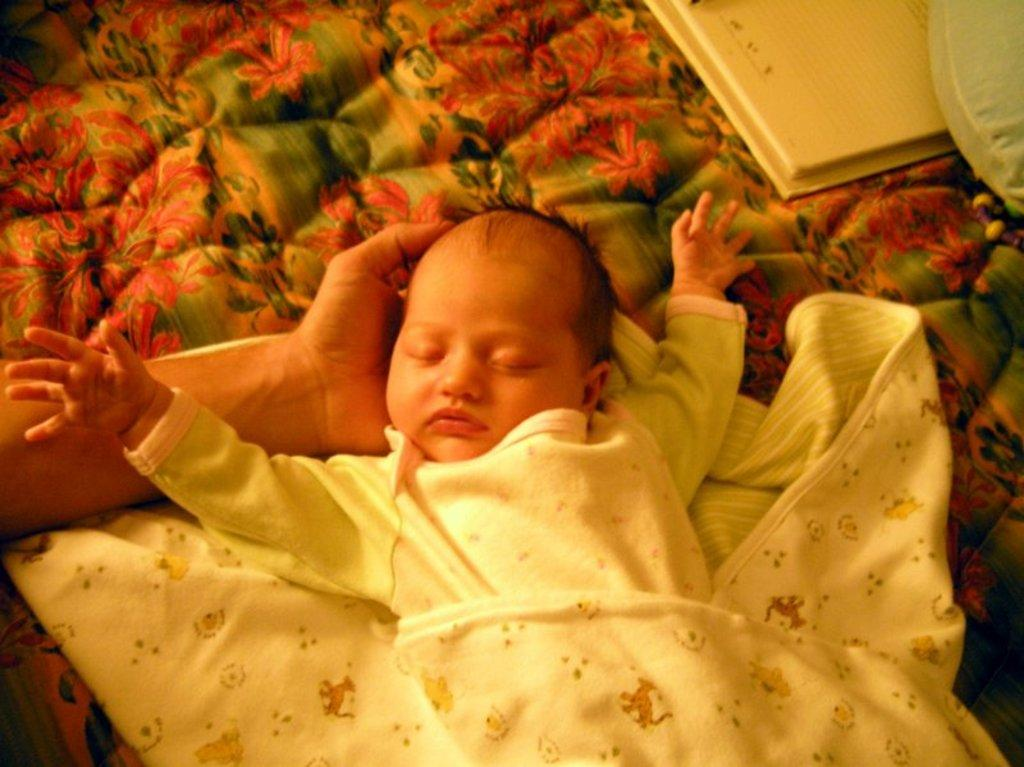What is the main subject of the image? There is a child in the image. What is the child wearing? The child is wearing a white dress. What other objects can be seen in the image? There is a cloth and a person's hand in the image. What is the color of the cloth? There is a white color cloth in the image. Can you tell me how many errors the child is correcting in the image? There is no indication of any errors being corrected in the image; it simply shows a child wearing a white dress with a cloth and a person's hand nearby. 